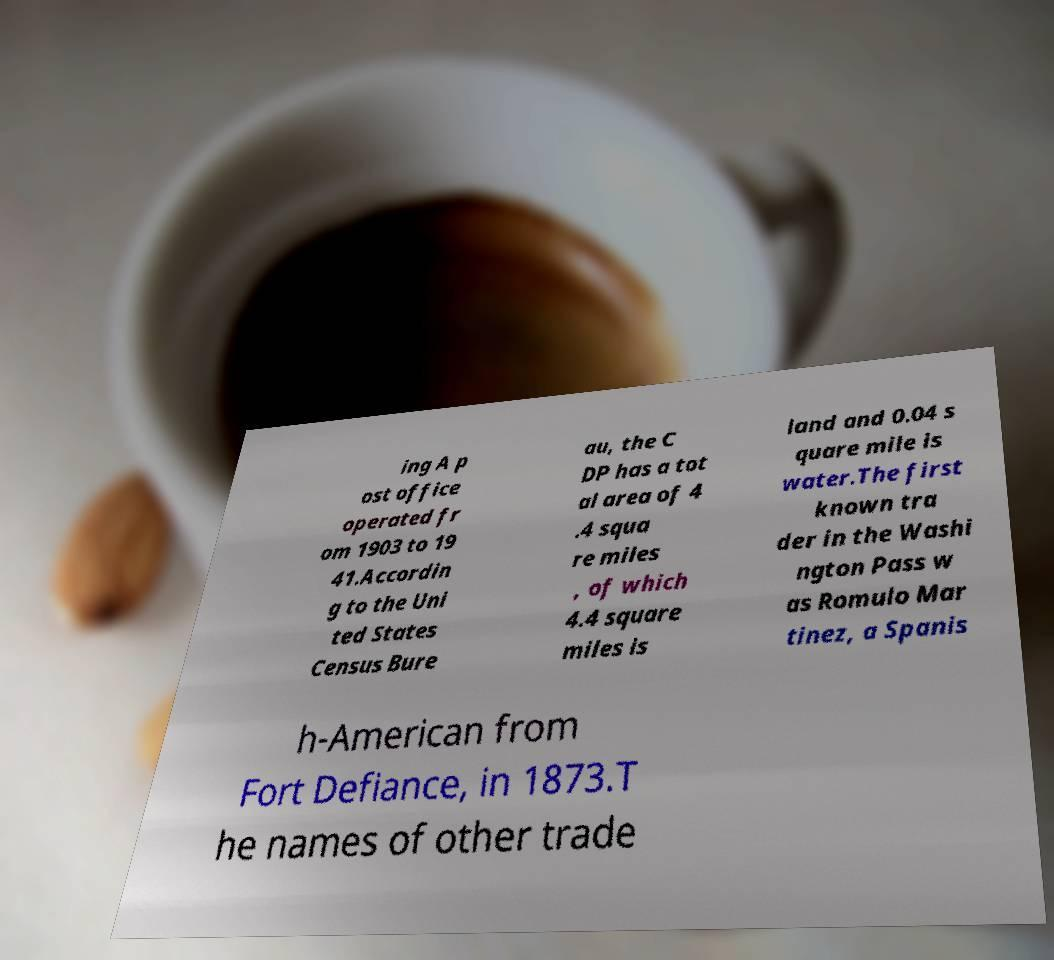Can you accurately transcribe the text from the provided image for me? ing A p ost office operated fr om 1903 to 19 41.Accordin g to the Uni ted States Census Bure au, the C DP has a tot al area of 4 .4 squa re miles , of which 4.4 square miles is land and 0.04 s quare mile is water.The first known tra der in the Washi ngton Pass w as Romulo Mar tinez, a Spanis h-American from Fort Defiance, in 1873.T he names of other trade 